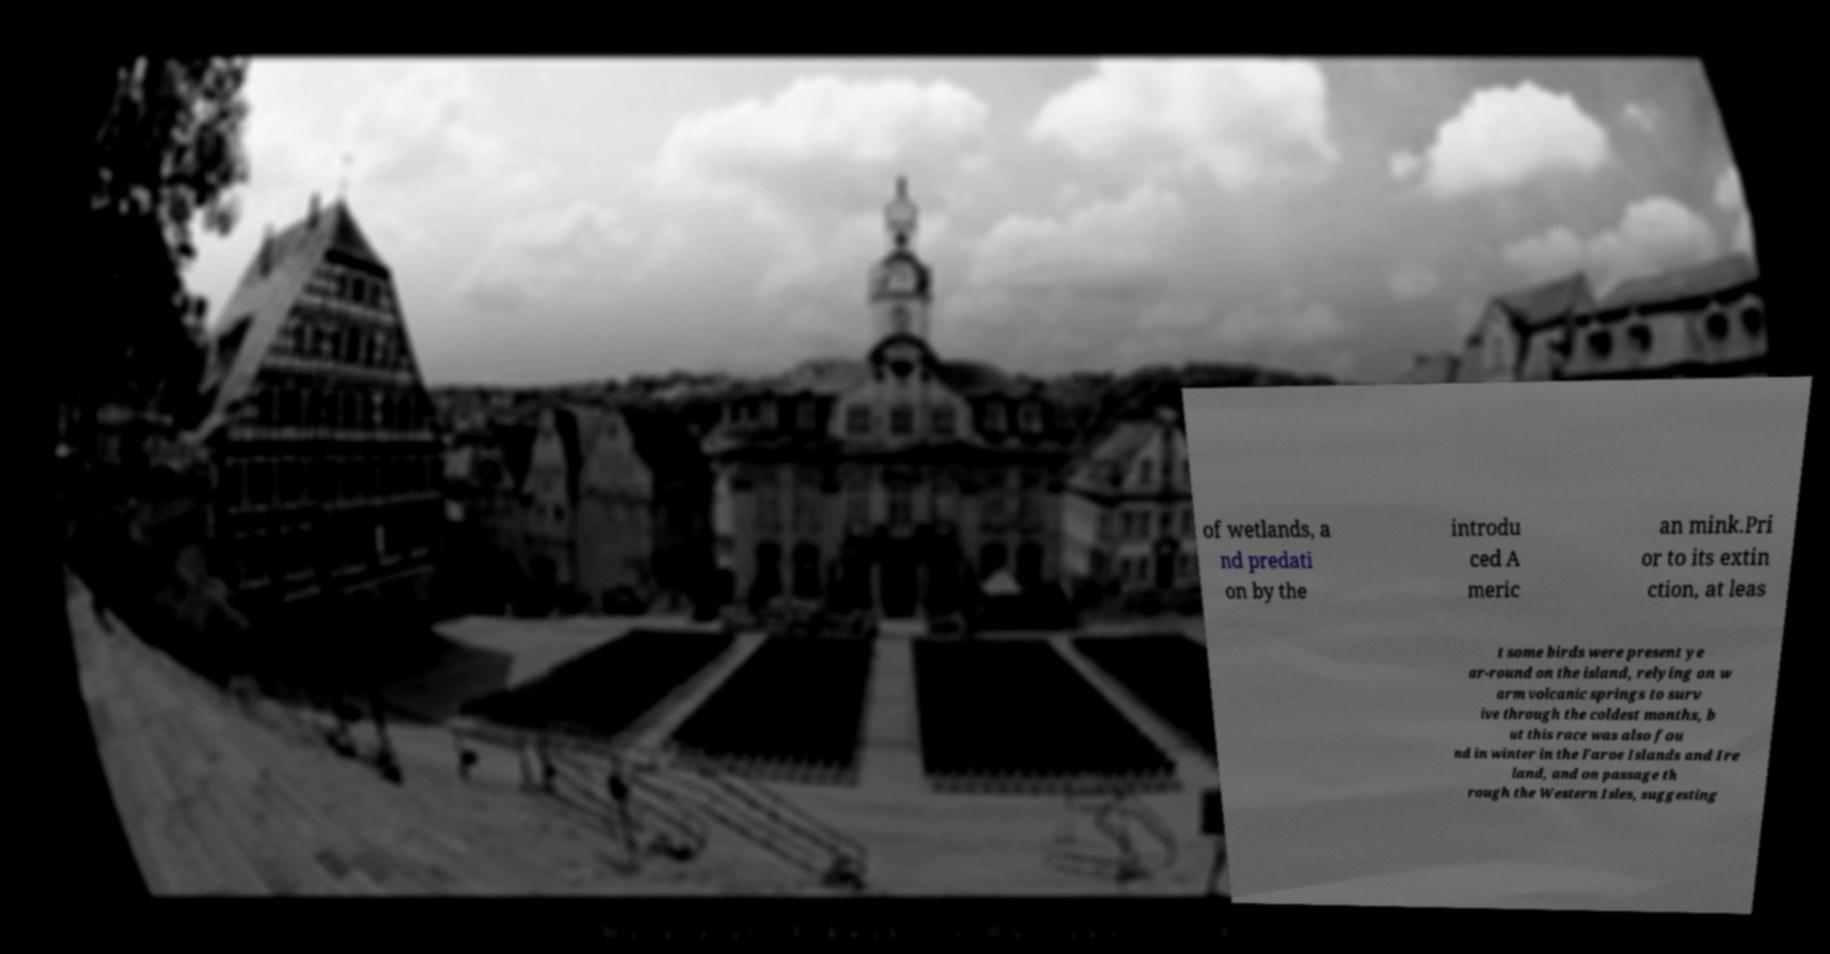I need the written content from this picture converted into text. Can you do that? of wetlands, a nd predati on by the introdu ced A meric an mink.Pri or to its extin ction, at leas t some birds were present ye ar-round on the island, relying on w arm volcanic springs to surv ive through the coldest months, b ut this race was also fou nd in winter in the Faroe Islands and Ire land, and on passage th rough the Western Isles, suggesting 